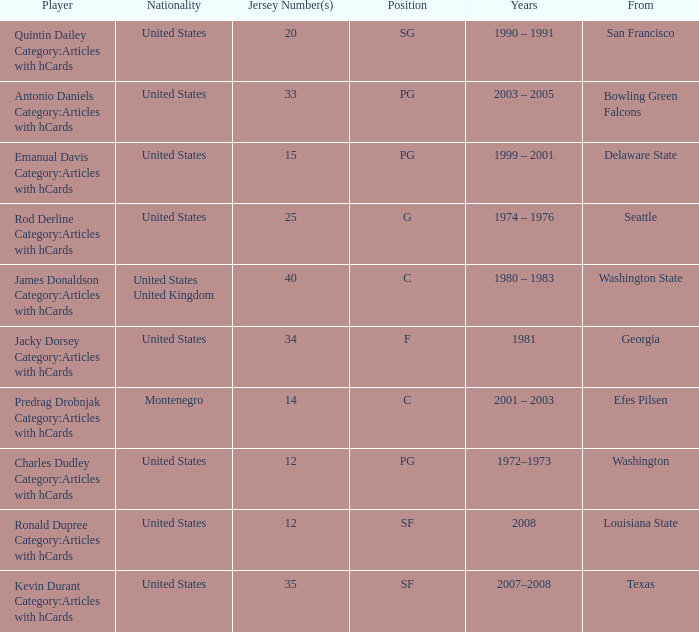What college was the player with the jersey number of 34 from? Georgia. 